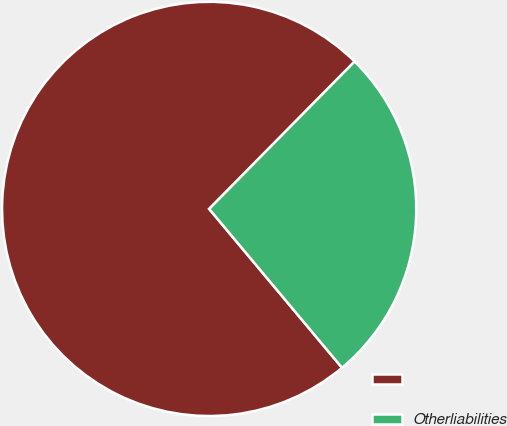Convert chart to OTSL. <chart><loc_0><loc_0><loc_500><loc_500><pie_chart><ecel><fcel>Otherliabilities<nl><fcel>73.48%<fcel>26.52%<nl></chart> 